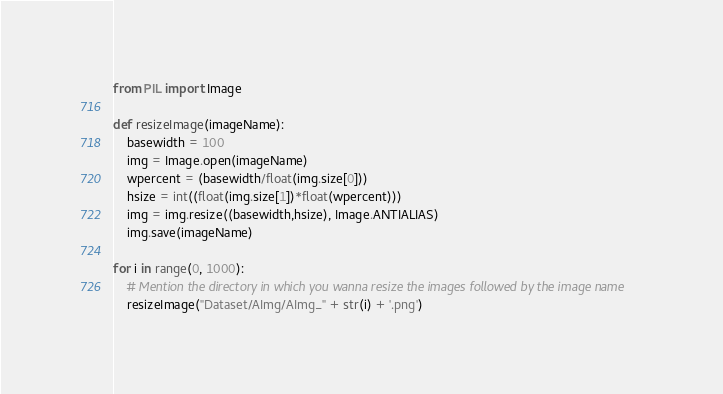<code> <loc_0><loc_0><loc_500><loc_500><_Python_>from PIL import Image

def resizeImage(imageName):
    basewidth = 100
    img = Image.open(imageName)
    wpercent = (basewidth/float(img.size[0]))
    hsize = int((float(img.size[1])*float(wpercent)))
    img = img.resize((basewidth,hsize), Image.ANTIALIAS)
    img.save(imageName)

for i in range(0, 1000):
    # Mention the directory in which you wanna resize the images followed by the image name
    resizeImage("Dataset/AImg/AImg_" + str(i) + '.png')


</code> 